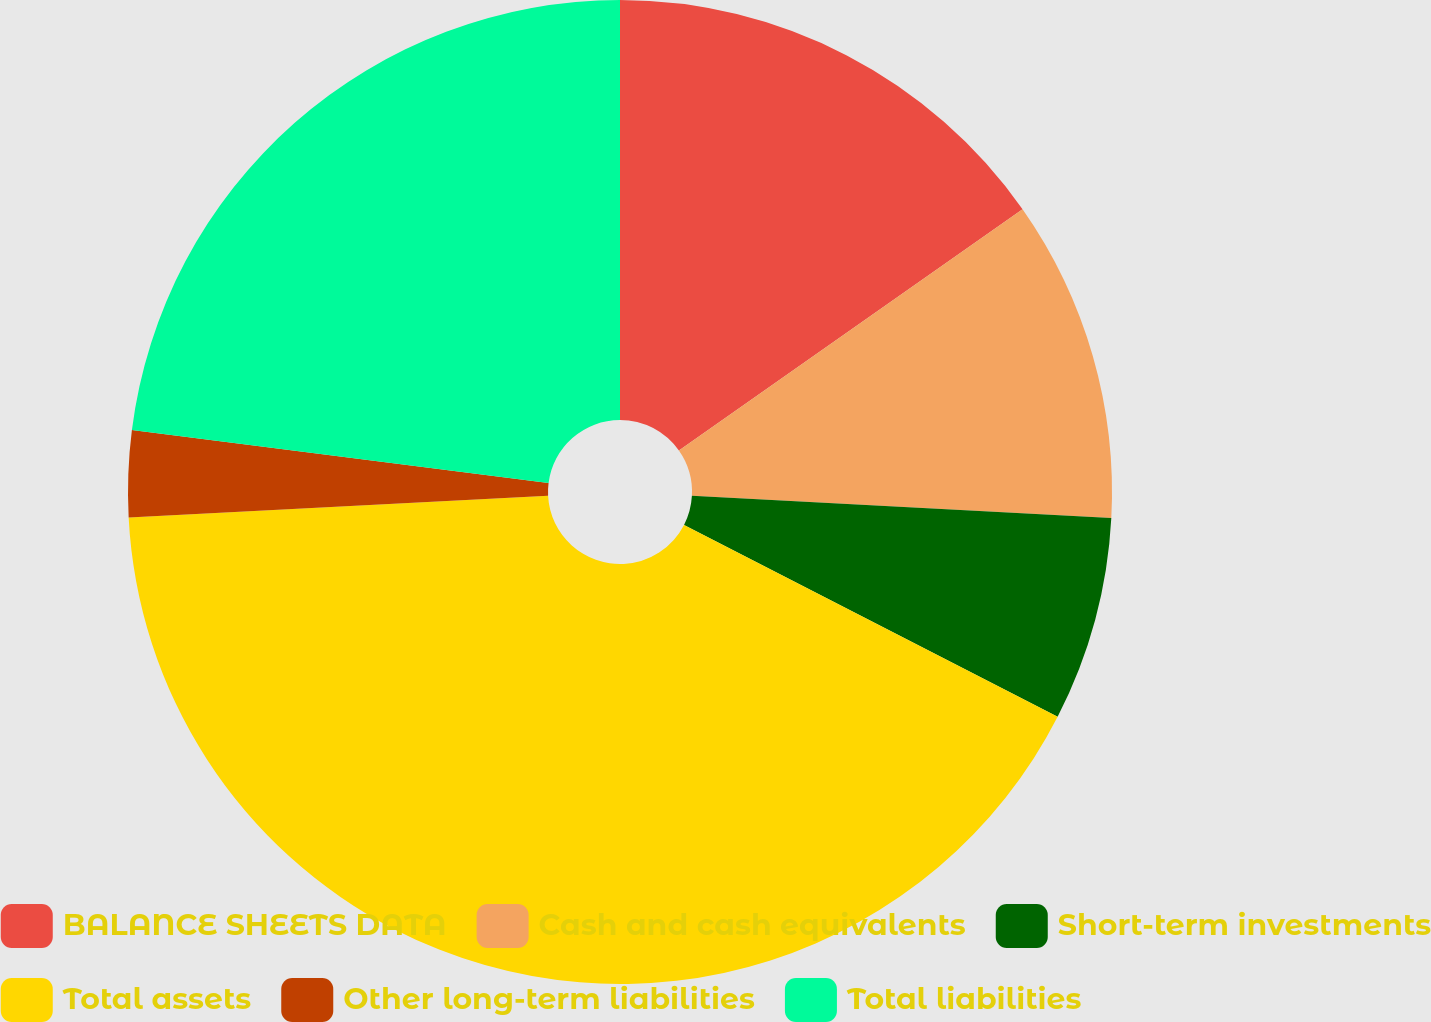Convert chart to OTSL. <chart><loc_0><loc_0><loc_500><loc_500><pie_chart><fcel>BALANCE SHEETS DATA<fcel>Cash and cash equivalents<fcel>Short-term investments<fcel>Total assets<fcel>Other long-term liabilities<fcel>Total liabilities<nl><fcel>15.25%<fcel>10.59%<fcel>6.71%<fcel>41.62%<fcel>2.83%<fcel>22.99%<nl></chart> 